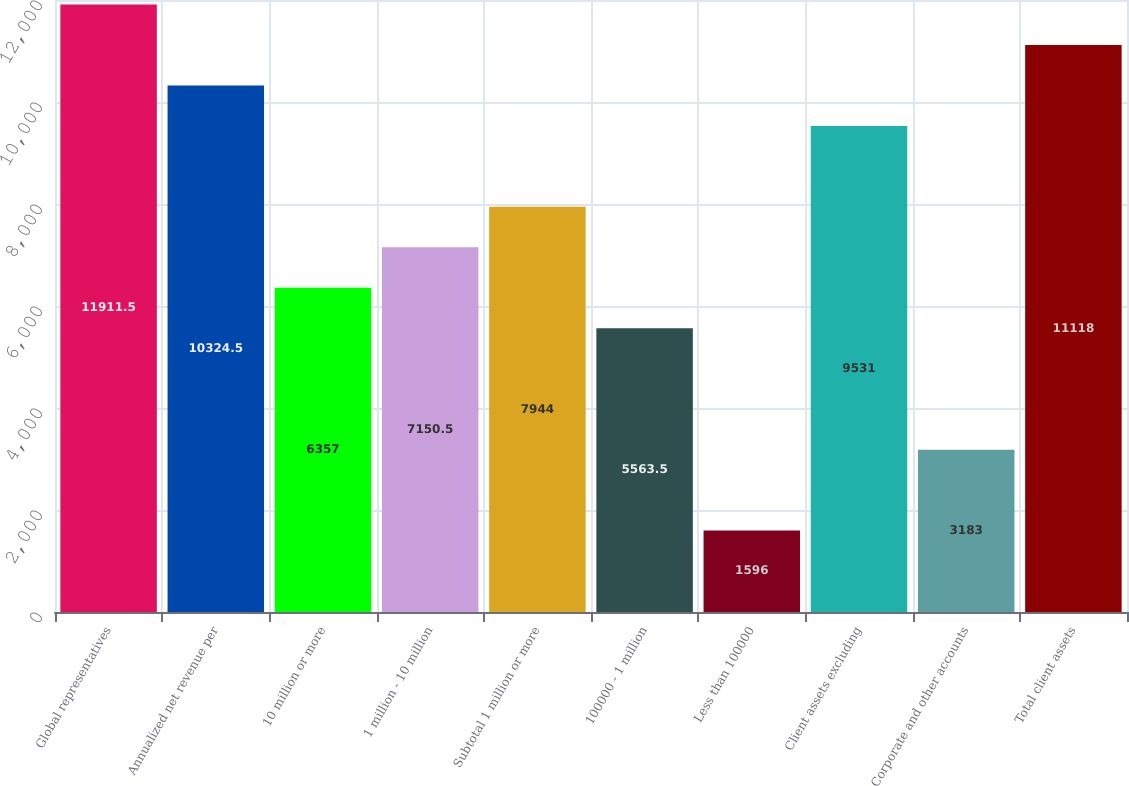<chart> <loc_0><loc_0><loc_500><loc_500><bar_chart><fcel>Global representatives<fcel>Annualized net revenue per<fcel>10 million or more<fcel>1 million - 10 million<fcel>Subtotal 1 million or more<fcel>100000 - 1 million<fcel>Less than 100000<fcel>Client assets excluding<fcel>Corporate and other accounts<fcel>Total client assets<nl><fcel>11911.5<fcel>10324.5<fcel>6357<fcel>7150.5<fcel>7944<fcel>5563.5<fcel>1596<fcel>9531<fcel>3183<fcel>11118<nl></chart> 